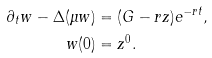<formula> <loc_0><loc_0><loc_500><loc_500>\partial _ { t } w - \Delta ( \mu w ) & = ( G - r z ) e ^ { - r t } , \\ w ( 0 ) & = z ^ { 0 } .</formula> 